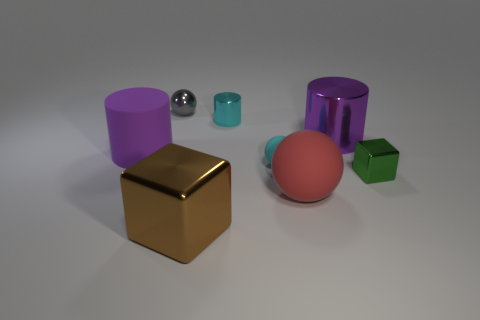Subtract all small balls. How many balls are left? 1 Subtract all yellow blocks. How many purple cylinders are left? 2 Add 1 large cyan balls. How many objects exist? 9 Subtract 2 cylinders. How many cylinders are left? 1 Subtract all cubes. How many objects are left? 6 Subtract all brown cylinders. Subtract all yellow spheres. How many cylinders are left? 3 Subtract all big red spheres. Subtract all cyan metal objects. How many objects are left? 6 Add 7 cyan rubber spheres. How many cyan rubber spheres are left? 8 Add 8 green matte cylinders. How many green matte cylinders exist? 8 Subtract 1 cyan spheres. How many objects are left? 7 